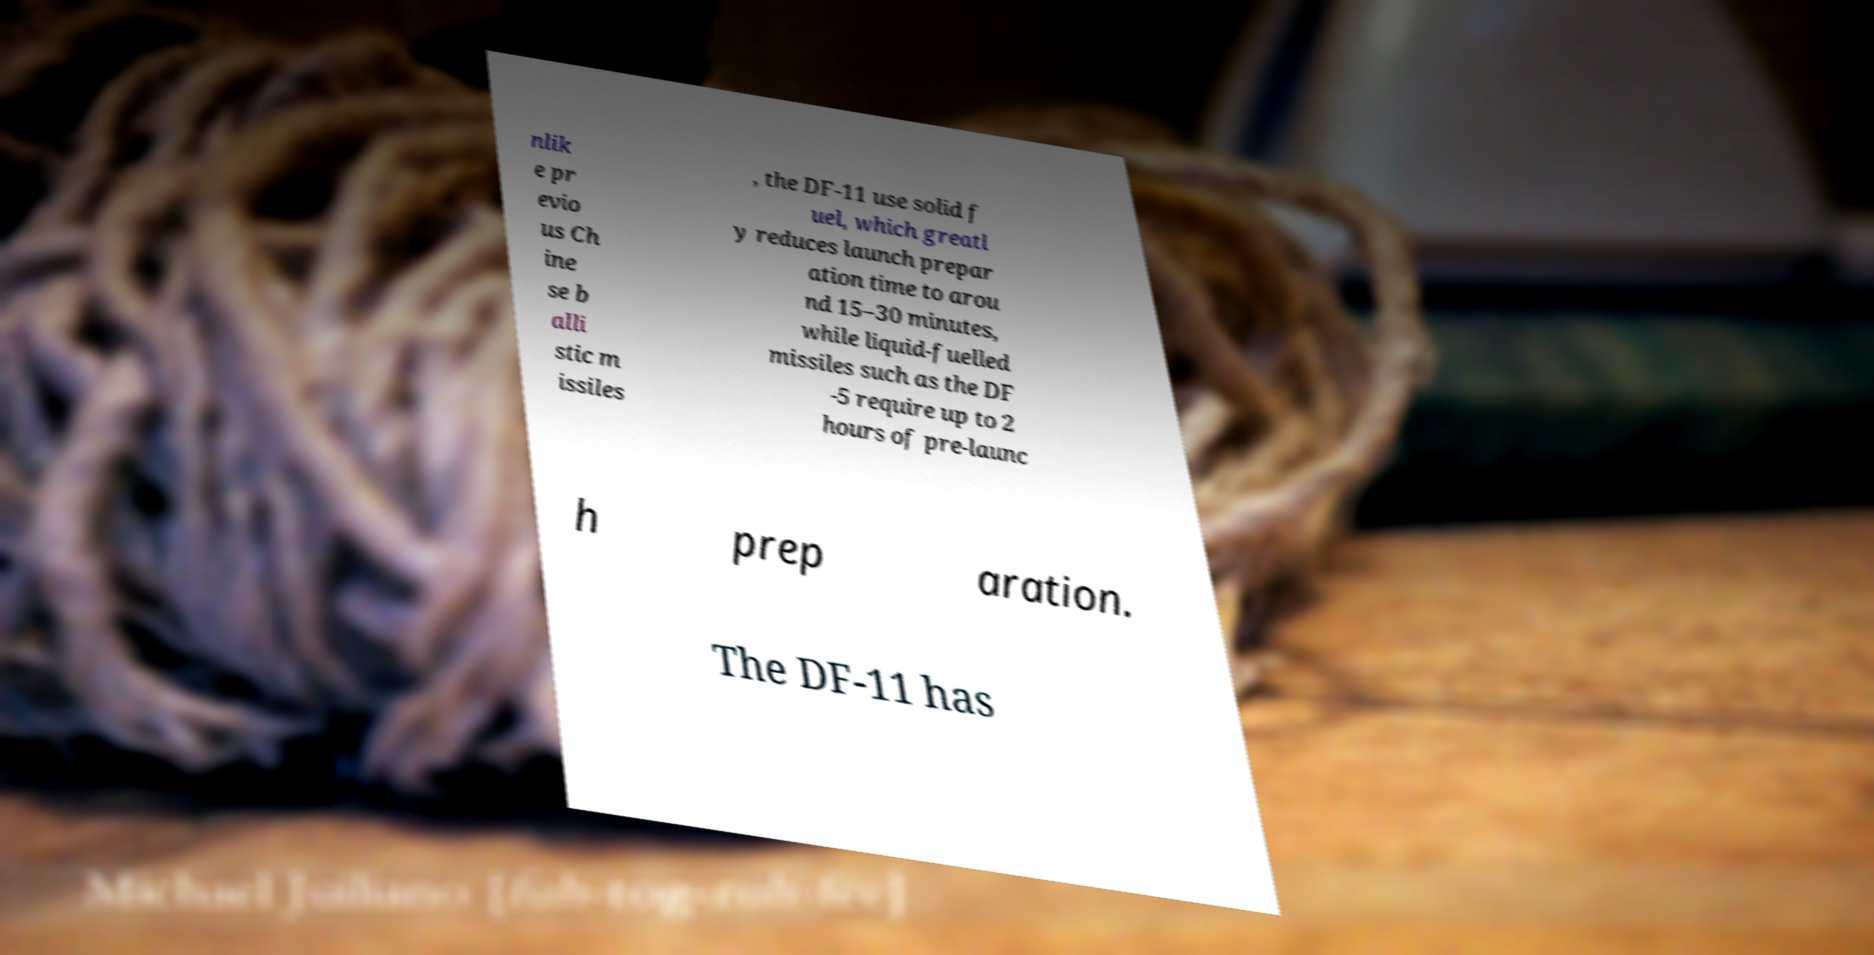Can you accurately transcribe the text from the provided image for me? nlik e pr evio us Ch ine se b alli stic m issiles , the DF-11 use solid f uel, which greatl y reduces launch prepar ation time to arou nd 15–30 minutes, while liquid-fuelled missiles such as the DF -5 require up to 2 hours of pre-launc h prep aration. The DF-11 has 